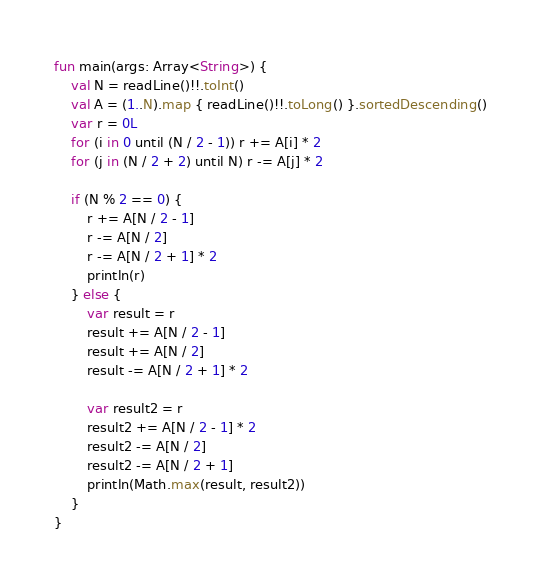Convert code to text. <code><loc_0><loc_0><loc_500><loc_500><_Kotlin_>fun main(args: Array<String>) {
    val N = readLine()!!.toInt()
    val A = (1..N).map { readLine()!!.toLong() }.sortedDescending()
    var r = 0L
    for (i in 0 until (N / 2 - 1)) r += A[i] * 2
    for (j in (N / 2 + 2) until N) r -= A[j] * 2

    if (N % 2 == 0) {
        r += A[N / 2 - 1]
        r -= A[N / 2]
        r -= A[N / 2 + 1] * 2
        println(r)
    } else {
        var result = r
        result += A[N / 2 - 1]
        result += A[N / 2]
        result -= A[N / 2 + 1] * 2

        var result2 = r
        result2 += A[N / 2 - 1] * 2
        result2 -= A[N / 2]
        result2 -= A[N / 2 + 1]
        println(Math.max(result, result2))
    }
}</code> 